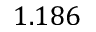Convert formula to latex. <formula><loc_0><loc_0><loc_500><loc_500>1 . 1 8 6</formula> 